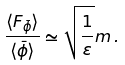<formula> <loc_0><loc_0><loc_500><loc_500>\frac { \langle F _ { \bar { \phi } } \rangle } { \langle \bar { \phi } \rangle } \simeq \sqrt { \frac { 1 } { \varepsilon } } m \, .</formula> 